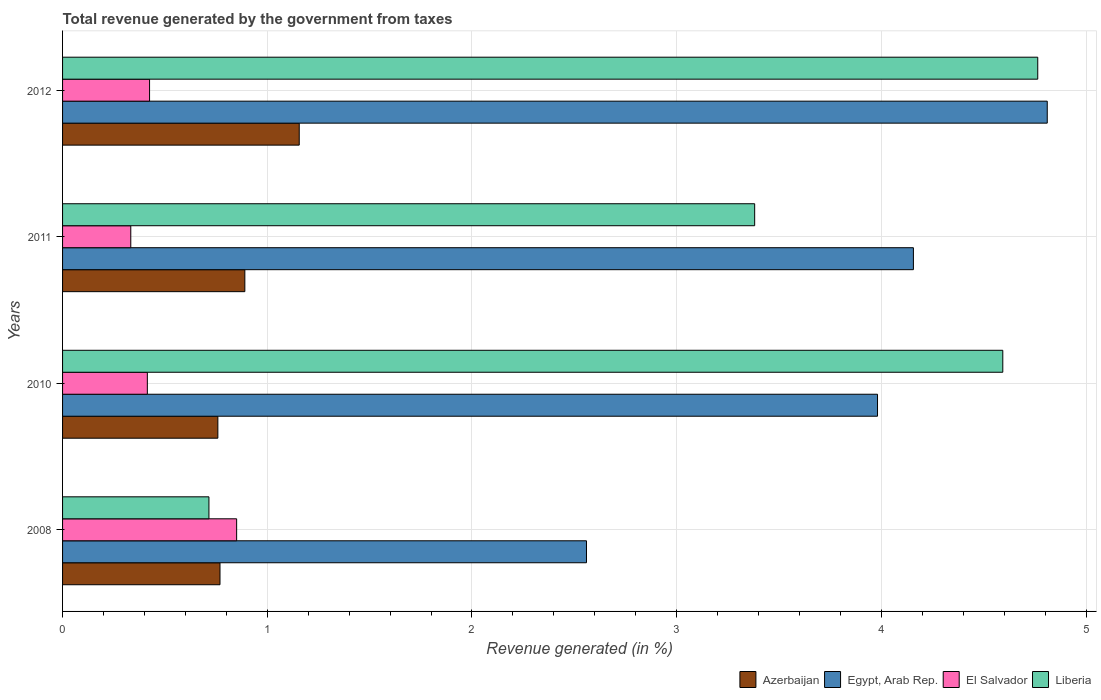How many different coloured bars are there?
Your answer should be compact. 4. Are the number of bars per tick equal to the number of legend labels?
Provide a succinct answer. Yes. Are the number of bars on each tick of the Y-axis equal?
Keep it short and to the point. Yes. How many bars are there on the 4th tick from the top?
Your answer should be very brief. 4. What is the label of the 1st group of bars from the top?
Your answer should be very brief. 2012. In how many cases, is the number of bars for a given year not equal to the number of legend labels?
Offer a terse response. 0. What is the total revenue generated in Egypt, Arab Rep. in 2012?
Your answer should be very brief. 4.81. Across all years, what is the maximum total revenue generated in Egypt, Arab Rep.?
Offer a terse response. 4.81. Across all years, what is the minimum total revenue generated in Egypt, Arab Rep.?
Your response must be concise. 2.56. What is the total total revenue generated in Liberia in the graph?
Give a very brief answer. 13.45. What is the difference between the total revenue generated in Azerbaijan in 2008 and that in 2010?
Provide a succinct answer. 0.01. What is the difference between the total revenue generated in Liberia in 2008 and the total revenue generated in Azerbaijan in 2012?
Your answer should be very brief. -0.44. What is the average total revenue generated in Liberia per year?
Make the answer very short. 3.36. In the year 2012, what is the difference between the total revenue generated in El Salvador and total revenue generated in Egypt, Arab Rep.?
Your response must be concise. -4.39. In how many years, is the total revenue generated in Egypt, Arab Rep. greater than 4 %?
Offer a very short reply. 2. What is the ratio of the total revenue generated in Liberia in 2010 to that in 2011?
Offer a very short reply. 1.36. Is the total revenue generated in Liberia in 2010 less than that in 2012?
Make the answer very short. Yes. What is the difference between the highest and the second highest total revenue generated in Liberia?
Your response must be concise. 0.17. What is the difference between the highest and the lowest total revenue generated in Liberia?
Your answer should be compact. 4.05. Is the sum of the total revenue generated in El Salvador in 2008 and 2010 greater than the maximum total revenue generated in Azerbaijan across all years?
Provide a succinct answer. Yes. Is it the case that in every year, the sum of the total revenue generated in El Salvador and total revenue generated in Liberia is greater than the sum of total revenue generated in Azerbaijan and total revenue generated in Egypt, Arab Rep.?
Provide a short and direct response. No. What does the 4th bar from the top in 2008 represents?
Keep it short and to the point. Azerbaijan. What does the 2nd bar from the bottom in 2010 represents?
Provide a short and direct response. Egypt, Arab Rep. How many years are there in the graph?
Offer a very short reply. 4. What is the difference between two consecutive major ticks on the X-axis?
Offer a terse response. 1. Are the values on the major ticks of X-axis written in scientific E-notation?
Ensure brevity in your answer.  No. Does the graph contain any zero values?
Provide a succinct answer. No. Where does the legend appear in the graph?
Your response must be concise. Bottom right. How many legend labels are there?
Provide a succinct answer. 4. How are the legend labels stacked?
Offer a terse response. Horizontal. What is the title of the graph?
Give a very brief answer. Total revenue generated by the government from taxes. Does "South Africa" appear as one of the legend labels in the graph?
Your response must be concise. No. What is the label or title of the X-axis?
Offer a terse response. Revenue generated (in %). What is the label or title of the Y-axis?
Ensure brevity in your answer.  Years. What is the Revenue generated (in %) of Azerbaijan in 2008?
Your response must be concise. 0.77. What is the Revenue generated (in %) of Egypt, Arab Rep. in 2008?
Offer a very short reply. 2.56. What is the Revenue generated (in %) of El Salvador in 2008?
Give a very brief answer. 0.85. What is the Revenue generated (in %) in Liberia in 2008?
Offer a terse response. 0.72. What is the Revenue generated (in %) of Azerbaijan in 2010?
Ensure brevity in your answer.  0.76. What is the Revenue generated (in %) in Egypt, Arab Rep. in 2010?
Offer a terse response. 3.98. What is the Revenue generated (in %) of El Salvador in 2010?
Make the answer very short. 0.41. What is the Revenue generated (in %) in Liberia in 2010?
Provide a short and direct response. 4.59. What is the Revenue generated (in %) of Azerbaijan in 2011?
Your answer should be very brief. 0.89. What is the Revenue generated (in %) of Egypt, Arab Rep. in 2011?
Provide a succinct answer. 4.16. What is the Revenue generated (in %) of El Salvador in 2011?
Your answer should be compact. 0.33. What is the Revenue generated (in %) in Liberia in 2011?
Your answer should be very brief. 3.38. What is the Revenue generated (in %) in Azerbaijan in 2012?
Your answer should be very brief. 1.16. What is the Revenue generated (in %) in Egypt, Arab Rep. in 2012?
Provide a succinct answer. 4.81. What is the Revenue generated (in %) of El Salvador in 2012?
Your response must be concise. 0.42. What is the Revenue generated (in %) of Liberia in 2012?
Keep it short and to the point. 4.76. Across all years, what is the maximum Revenue generated (in %) in Azerbaijan?
Offer a very short reply. 1.16. Across all years, what is the maximum Revenue generated (in %) in Egypt, Arab Rep.?
Your answer should be compact. 4.81. Across all years, what is the maximum Revenue generated (in %) of El Salvador?
Make the answer very short. 0.85. Across all years, what is the maximum Revenue generated (in %) in Liberia?
Keep it short and to the point. 4.76. Across all years, what is the minimum Revenue generated (in %) in Azerbaijan?
Give a very brief answer. 0.76. Across all years, what is the minimum Revenue generated (in %) of Egypt, Arab Rep.?
Keep it short and to the point. 2.56. Across all years, what is the minimum Revenue generated (in %) in El Salvador?
Your answer should be compact. 0.33. Across all years, what is the minimum Revenue generated (in %) of Liberia?
Your answer should be very brief. 0.72. What is the total Revenue generated (in %) of Azerbaijan in the graph?
Your answer should be compact. 3.57. What is the total Revenue generated (in %) in Egypt, Arab Rep. in the graph?
Give a very brief answer. 15.51. What is the total Revenue generated (in %) in El Salvador in the graph?
Provide a short and direct response. 2.02. What is the total Revenue generated (in %) in Liberia in the graph?
Your answer should be compact. 13.45. What is the difference between the Revenue generated (in %) of Azerbaijan in 2008 and that in 2010?
Your answer should be very brief. 0.01. What is the difference between the Revenue generated (in %) of Egypt, Arab Rep. in 2008 and that in 2010?
Keep it short and to the point. -1.42. What is the difference between the Revenue generated (in %) in El Salvador in 2008 and that in 2010?
Your response must be concise. 0.44. What is the difference between the Revenue generated (in %) of Liberia in 2008 and that in 2010?
Offer a very short reply. -3.88. What is the difference between the Revenue generated (in %) in Azerbaijan in 2008 and that in 2011?
Provide a short and direct response. -0.12. What is the difference between the Revenue generated (in %) of Egypt, Arab Rep. in 2008 and that in 2011?
Make the answer very short. -1.6. What is the difference between the Revenue generated (in %) of El Salvador in 2008 and that in 2011?
Your answer should be very brief. 0.52. What is the difference between the Revenue generated (in %) in Liberia in 2008 and that in 2011?
Offer a very short reply. -2.67. What is the difference between the Revenue generated (in %) of Azerbaijan in 2008 and that in 2012?
Your answer should be very brief. -0.39. What is the difference between the Revenue generated (in %) of Egypt, Arab Rep. in 2008 and that in 2012?
Keep it short and to the point. -2.25. What is the difference between the Revenue generated (in %) of El Salvador in 2008 and that in 2012?
Your answer should be compact. 0.43. What is the difference between the Revenue generated (in %) of Liberia in 2008 and that in 2012?
Give a very brief answer. -4.05. What is the difference between the Revenue generated (in %) in Azerbaijan in 2010 and that in 2011?
Provide a succinct answer. -0.13. What is the difference between the Revenue generated (in %) of Egypt, Arab Rep. in 2010 and that in 2011?
Provide a short and direct response. -0.18. What is the difference between the Revenue generated (in %) in El Salvador in 2010 and that in 2011?
Give a very brief answer. 0.08. What is the difference between the Revenue generated (in %) in Liberia in 2010 and that in 2011?
Offer a terse response. 1.21. What is the difference between the Revenue generated (in %) of Azerbaijan in 2010 and that in 2012?
Your answer should be very brief. -0.4. What is the difference between the Revenue generated (in %) in Egypt, Arab Rep. in 2010 and that in 2012?
Ensure brevity in your answer.  -0.83. What is the difference between the Revenue generated (in %) in El Salvador in 2010 and that in 2012?
Offer a terse response. -0.01. What is the difference between the Revenue generated (in %) of Liberia in 2010 and that in 2012?
Make the answer very short. -0.17. What is the difference between the Revenue generated (in %) in Azerbaijan in 2011 and that in 2012?
Give a very brief answer. -0.27. What is the difference between the Revenue generated (in %) in Egypt, Arab Rep. in 2011 and that in 2012?
Offer a terse response. -0.65. What is the difference between the Revenue generated (in %) of El Salvador in 2011 and that in 2012?
Make the answer very short. -0.09. What is the difference between the Revenue generated (in %) of Liberia in 2011 and that in 2012?
Keep it short and to the point. -1.38. What is the difference between the Revenue generated (in %) in Azerbaijan in 2008 and the Revenue generated (in %) in Egypt, Arab Rep. in 2010?
Provide a short and direct response. -3.21. What is the difference between the Revenue generated (in %) of Azerbaijan in 2008 and the Revenue generated (in %) of El Salvador in 2010?
Offer a very short reply. 0.35. What is the difference between the Revenue generated (in %) in Azerbaijan in 2008 and the Revenue generated (in %) in Liberia in 2010?
Offer a very short reply. -3.82. What is the difference between the Revenue generated (in %) in Egypt, Arab Rep. in 2008 and the Revenue generated (in %) in El Salvador in 2010?
Provide a succinct answer. 2.15. What is the difference between the Revenue generated (in %) of Egypt, Arab Rep. in 2008 and the Revenue generated (in %) of Liberia in 2010?
Give a very brief answer. -2.03. What is the difference between the Revenue generated (in %) of El Salvador in 2008 and the Revenue generated (in %) of Liberia in 2010?
Ensure brevity in your answer.  -3.74. What is the difference between the Revenue generated (in %) in Azerbaijan in 2008 and the Revenue generated (in %) in Egypt, Arab Rep. in 2011?
Offer a terse response. -3.39. What is the difference between the Revenue generated (in %) in Azerbaijan in 2008 and the Revenue generated (in %) in El Salvador in 2011?
Offer a very short reply. 0.44. What is the difference between the Revenue generated (in %) of Azerbaijan in 2008 and the Revenue generated (in %) of Liberia in 2011?
Give a very brief answer. -2.61. What is the difference between the Revenue generated (in %) of Egypt, Arab Rep. in 2008 and the Revenue generated (in %) of El Salvador in 2011?
Offer a very short reply. 2.23. What is the difference between the Revenue generated (in %) in Egypt, Arab Rep. in 2008 and the Revenue generated (in %) in Liberia in 2011?
Ensure brevity in your answer.  -0.82. What is the difference between the Revenue generated (in %) in El Salvador in 2008 and the Revenue generated (in %) in Liberia in 2011?
Your answer should be very brief. -2.53. What is the difference between the Revenue generated (in %) in Azerbaijan in 2008 and the Revenue generated (in %) in Egypt, Arab Rep. in 2012?
Provide a short and direct response. -4.04. What is the difference between the Revenue generated (in %) in Azerbaijan in 2008 and the Revenue generated (in %) in El Salvador in 2012?
Your answer should be very brief. 0.34. What is the difference between the Revenue generated (in %) in Azerbaijan in 2008 and the Revenue generated (in %) in Liberia in 2012?
Provide a succinct answer. -4. What is the difference between the Revenue generated (in %) of Egypt, Arab Rep. in 2008 and the Revenue generated (in %) of El Salvador in 2012?
Give a very brief answer. 2.13. What is the difference between the Revenue generated (in %) of Egypt, Arab Rep. in 2008 and the Revenue generated (in %) of Liberia in 2012?
Your response must be concise. -2.2. What is the difference between the Revenue generated (in %) of El Salvador in 2008 and the Revenue generated (in %) of Liberia in 2012?
Your answer should be compact. -3.91. What is the difference between the Revenue generated (in %) of Azerbaijan in 2010 and the Revenue generated (in %) of Egypt, Arab Rep. in 2011?
Offer a terse response. -3.4. What is the difference between the Revenue generated (in %) of Azerbaijan in 2010 and the Revenue generated (in %) of El Salvador in 2011?
Provide a succinct answer. 0.43. What is the difference between the Revenue generated (in %) of Azerbaijan in 2010 and the Revenue generated (in %) of Liberia in 2011?
Provide a succinct answer. -2.62. What is the difference between the Revenue generated (in %) in Egypt, Arab Rep. in 2010 and the Revenue generated (in %) in El Salvador in 2011?
Give a very brief answer. 3.65. What is the difference between the Revenue generated (in %) in Egypt, Arab Rep. in 2010 and the Revenue generated (in %) in Liberia in 2011?
Give a very brief answer. 0.6. What is the difference between the Revenue generated (in %) in El Salvador in 2010 and the Revenue generated (in %) in Liberia in 2011?
Your answer should be compact. -2.97. What is the difference between the Revenue generated (in %) in Azerbaijan in 2010 and the Revenue generated (in %) in Egypt, Arab Rep. in 2012?
Your answer should be compact. -4.05. What is the difference between the Revenue generated (in %) of Azerbaijan in 2010 and the Revenue generated (in %) of El Salvador in 2012?
Make the answer very short. 0.33. What is the difference between the Revenue generated (in %) in Azerbaijan in 2010 and the Revenue generated (in %) in Liberia in 2012?
Make the answer very short. -4.01. What is the difference between the Revenue generated (in %) in Egypt, Arab Rep. in 2010 and the Revenue generated (in %) in El Salvador in 2012?
Offer a terse response. 3.56. What is the difference between the Revenue generated (in %) of Egypt, Arab Rep. in 2010 and the Revenue generated (in %) of Liberia in 2012?
Your answer should be very brief. -0.78. What is the difference between the Revenue generated (in %) of El Salvador in 2010 and the Revenue generated (in %) of Liberia in 2012?
Your answer should be very brief. -4.35. What is the difference between the Revenue generated (in %) in Azerbaijan in 2011 and the Revenue generated (in %) in Egypt, Arab Rep. in 2012?
Your answer should be very brief. -3.92. What is the difference between the Revenue generated (in %) of Azerbaijan in 2011 and the Revenue generated (in %) of El Salvador in 2012?
Offer a terse response. 0.47. What is the difference between the Revenue generated (in %) of Azerbaijan in 2011 and the Revenue generated (in %) of Liberia in 2012?
Ensure brevity in your answer.  -3.87. What is the difference between the Revenue generated (in %) of Egypt, Arab Rep. in 2011 and the Revenue generated (in %) of El Salvador in 2012?
Keep it short and to the point. 3.73. What is the difference between the Revenue generated (in %) in Egypt, Arab Rep. in 2011 and the Revenue generated (in %) in Liberia in 2012?
Give a very brief answer. -0.61. What is the difference between the Revenue generated (in %) in El Salvador in 2011 and the Revenue generated (in %) in Liberia in 2012?
Provide a succinct answer. -4.43. What is the average Revenue generated (in %) of Azerbaijan per year?
Ensure brevity in your answer.  0.89. What is the average Revenue generated (in %) of Egypt, Arab Rep. per year?
Ensure brevity in your answer.  3.88. What is the average Revenue generated (in %) in El Salvador per year?
Offer a very short reply. 0.51. What is the average Revenue generated (in %) in Liberia per year?
Your answer should be very brief. 3.36. In the year 2008, what is the difference between the Revenue generated (in %) in Azerbaijan and Revenue generated (in %) in Egypt, Arab Rep.?
Your answer should be compact. -1.79. In the year 2008, what is the difference between the Revenue generated (in %) of Azerbaijan and Revenue generated (in %) of El Salvador?
Provide a short and direct response. -0.08. In the year 2008, what is the difference between the Revenue generated (in %) in Azerbaijan and Revenue generated (in %) in Liberia?
Keep it short and to the point. 0.05. In the year 2008, what is the difference between the Revenue generated (in %) in Egypt, Arab Rep. and Revenue generated (in %) in El Salvador?
Provide a succinct answer. 1.71. In the year 2008, what is the difference between the Revenue generated (in %) of Egypt, Arab Rep. and Revenue generated (in %) of Liberia?
Offer a terse response. 1.84. In the year 2008, what is the difference between the Revenue generated (in %) of El Salvador and Revenue generated (in %) of Liberia?
Offer a terse response. 0.14. In the year 2010, what is the difference between the Revenue generated (in %) in Azerbaijan and Revenue generated (in %) in Egypt, Arab Rep.?
Your answer should be compact. -3.22. In the year 2010, what is the difference between the Revenue generated (in %) of Azerbaijan and Revenue generated (in %) of El Salvador?
Your answer should be compact. 0.34. In the year 2010, what is the difference between the Revenue generated (in %) of Azerbaijan and Revenue generated (in %) of Liberia?
Offer a very short reply. -3.83. In the year 2010, what is the difference between the Revenue generated (in %) of Egypt, Arab Rep. and Revenue generated (in %) of El Salvador?
Make the answer very short. 3.57. In the year 2010, what is the difference between the Revenue generated (in %) of Egypt, Arab Rep. and Revenue generated (in %) of Liberia?
Ensure brevity in your answer.  -0.61. In the year 2010, what is the difference between the Revenue generated (in %) in El Salvador and Revenue generated (in %) in Liberia?
Offer a very short reply. -4.18. In the year 2011, what is the difference between the Revenue generated (in %) of Azerbaijan and Revenue generated (in %) of Egypt, Arab Rep.?
Ensure brevity in your answer.  -3.27. In the year 2011, what is the difference between the Revenue generated (in %) of Azerbaijan and Revenue generated (in %) of El Salvador?
Your response must be concise. 0.56. In the year 2011, what is the difference between the Revenue generated (in %) of Azerbaijan and Revenue generated (in %) of Liberia?
Keep it short and to the point. -2.49. In the year 2011, what is the difference between the Revenue generated (in %) of Egypt, Arab Rep. and Revenue generated (in %) of El Salvador?
Your answer should be very brief. 3.82. In the year 2011, what is the difference between the Revenue generated (in %) in Egypt, Arab Rep. and Revenue generated (in %) in Liberia?
Your answer should be very brief. 0.78. In the year 2011, what is the difference between the Revenue generated (in %) of El Salvador and Revenue generated (in %) of Liberia?
Give a very brief answer. -3.05. In the year 2012, what is the difference between the Revenue generated (in %) in Azerbaijan and Revenue generated (in %) in Egypt, Arab Rep.?
Offer a terse response. -3.65. In the year 2012, what is the difference between the Revenue generated (in %) in Azerbaijan and Revenue generated (in %) in El Salvador?
Offer a terse response. 0.73. In the year 2012, what is the difference between the Revenue generated (in %) of Azerbaijan and Revenue generated (in %) of Liberia?
Offer a terse response. -3.61. In the year 2012, what is the difference between the Revenue generated (in %) of Egypt, Arab Rep. and Revenue generated (in %) of El Salvador?
Make the answer very short. 4.39. In the year 2012, what is the difference between the Revenue generated (in %) of Egypt, Arab Rep. and Revenue generated (in %) of Liberia?
Your answer should be very brief. 0.05. In the year 2012, what is the difference between the Revenue generated (in %) of El Salvador and Revenue generated (in %) of Liberia?
Offer a terse response. -4.34. What is the ratio of the Revenue generated (in %) in Azerbaijan in 2008 to that in 2010?
Keep it short and to the point. 1.01. What is the ratio of the Revenue generated (in %) in Egypt, Arab Rep. in 2008 to that in 2010?
Your answer should be compact. 0.64. What is the ratio of the Revenue generated (in %) in El Salvador in 2008 to that in 2010?
Your answer should be very brief. 2.05. What is the ratio of the Revenue generated (in %) of Liberia in 2008 to that in 2010?
Provide a succinct answer. 0.16. What is the ratio of the Revenue generated (in %) in Azerbaijan in 2008 to that in 2011?
Offer a terse response. 0.86. What is the ratio of the Revenue generated (in %) of Egypt, Arab Rep. in 2008 to that in 2011?
Ensure brevity in your answer.  0.62. What is the ratio of the Revenue generated (in %) of El Salvador in 2008 to that in 2011?
Ensure brevity in your answer.  2.55. What is the ratio of the Revenue generated (in %) of Liberia in 2008 to that in 2011?
Offer a very short reply. 0.21. What is the ratio of the Revenue generated (in %) of Azerbaijan in 2008 to that in 2012?
Provide a short and direct response. 0.67. What is the ratio of the Revenue generated (in %) in Egypt, Arab Rep. in 2008 to that in 2012?
Provide a succinct answer. 0.53. What is the ratio of the Revenue generated (in %) of El Salvador in 2008 to that in 2012?
Keep it short and to the point. 2. What is the ratio of the Revenue generated (in %) in Liberia in 2008 to that in 2012?
Provide a succinct answer. 0.15. What is the ratio of the Revenue generated (in %) in Azerbaijan in 2010 to that in 2011?
Your response must be concise. 0.85. What is the ratio of the Revenue generated (in %) of Egypt, Arab Rep. in 2010 to that in 2011?
Your response must be concise. 0.96. What is the ratio of the Revenue generated (in %) of El Salvador in 2010 to that in 2011?
Your answer should be compact. 1.24. What is the ratio of the Revenue generated (in %) in Liberia in 2010 to that in 2011?
Keep it short and to the point. 1.36. What is the ratio of the Revenue generated (in %) of Azerbaijan in 2010 to that in 2012?
Give a very brief answer. 0.66. What is the ratio of the Revenue generated (in %) of Egypt, Arab Rep. in 2010 to that in 2012?
Offer a terse response. 0.83. What is the ratio of the Revenue generated (in %) in El Salvador in 2010 to that in 2012?
Give a very brief answer. 0.97. What is the ratio of the Revenue generated (in %) of Liberia in 2010 to that in 2012?
Ensure brevity in your answer.  0.96. What is the ratio of the Revenue generated (in %) of Azerbaijan in 2011 to that in 2012?
Your answer should be compact. 0.77. What is the ratio of the Revenue generated (in %) of Egypt, Arab Rep. in 2011 to that in 2012?
Keep it short and to the point. 0.86. What is the ratio of the Revenue generated (in %) in El Salvador in 2011 to that in 2012?
Provide a succinct answer. 0.78. What is the ratio of the Revenue generated (in %) of Liberia in 2011 to that in 2012?
Your answer should be compact. 0.71. What is the difference between the highest and the second highest Revenue generated (in %) of Azerbaijan?
Give a very brief answer. 0.27. What is the difference between the highest and the second highest Revenue generated (in %) of Egypt, Arab Rep.?
Your response must be concise. 0.65. What is the difference between the highest and the second highest Revenue generated (in %) of El Salvador?
Provide a short and direct response. 0.43. What is the difference between the highest and the second highest Revenue generated (in %) in Liberia?
Ensure brevity in your answer.  0.17. What is the difference between the highest and the lowest Revenue generated (in %) in Azerbaijan?
Your answer should be very brief. 0.4. What is the difference between the highest and the lowest Revenue generated (in %) of Egypt, Arab Rep.?
Give a very brief answer. 2.25. What is the difference between the highest and the lowest Revenue generated (in %) in El Salvador?
Your answer should be very brief. 0.52. What is the difference between the highest and the lowest Revenue generated (in %) of Liberia?
Give a very brief answer. 4.05. 